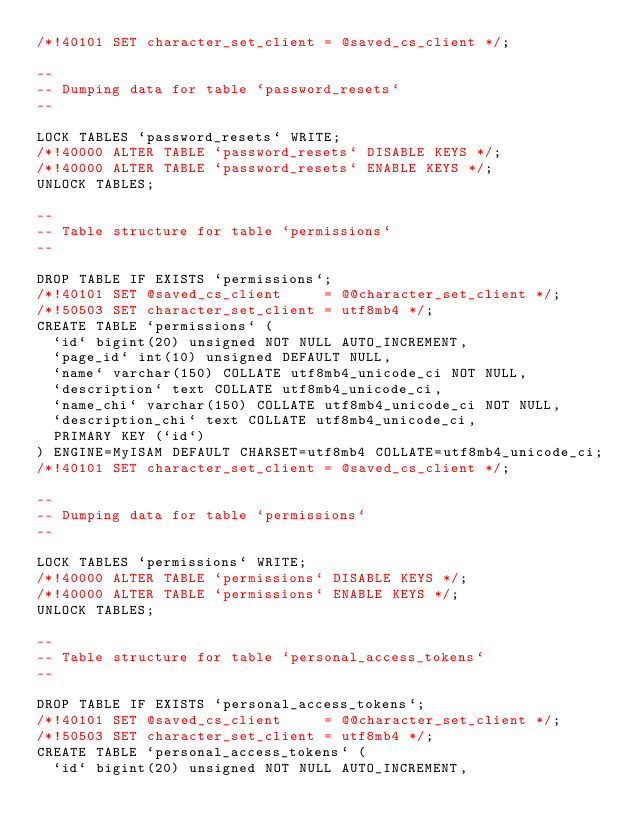<code> <loc_0><loc_0><loc_500><loc_500><_SQL_>/*!40101 SET character_set_client = @saved_cs_client */;

--
-- Dumping data for table `password_resets`
--

LOCK TABLES `password_resets` WRITE;
/*!40000 ALTER TABLE `password_resets` DISABLE KEYS */;
/*!40000 ALTER TABLE `password_resets` ENABLE KEYS */;
UNLOCK TABLES;

--
-- Table structure for table `permissions`
--

DROP TABLE IF EXISTS `permissions`;
/*!40101 SET @saved_cs_client     = @@character_set_client */;
/*!50503 SET character_set_client = utf8mb4 */;
CREATE TABLE `permissions` (
  `id` bigint(20) unsigned NOT NULL AUTO_INCREMENT,
  `page_id` int(10) unsigned DEFAULT NULL,
  `name` varchar(150) COLLATE utf8mb4_unicode_ci NOT NULL,
  `description` text COLLATE utf8mb4_unicode_ci,
  `name_chi` varchar(150) COLLATE utf8mb4_unicode_ci NOT NULL,
  `description_chi` text COLLATE utf8mb4_unicode_ci,
  PRIMARY KEY (`id`)
) ENGINE=MyISAM DEFAULT CHARSET=utf8mb4 COLLATE=utf8mb4_unicode_ci;
/*!40101 SET character_set_client = @saved_cs_client */;

--
-- Dumping data for table `permissions`
--

LOCK TABLES `permissions` WRITE;
/*!40000 ALTER TABLE `permissions` DISABLE KEYS */;
/*!40000 ALTER TABLE `permissions` ENABLE KEYS */;
UNLOCK TABLES;

--
-- Table structure for table `personal_access_tokens`
--

DROP TABLE IF EXISTS `personal_access_tokens`;
/*!40101 SET @saved_cs_client     = @@character_set_client */;
/*!50503 SET character_set_client = utf8mb4 */;
CREATE TABLE `personal_access_tokens` (
  `id` bigint(20) unsigned NOT NULL AUTO_INCREMENT,</code> 